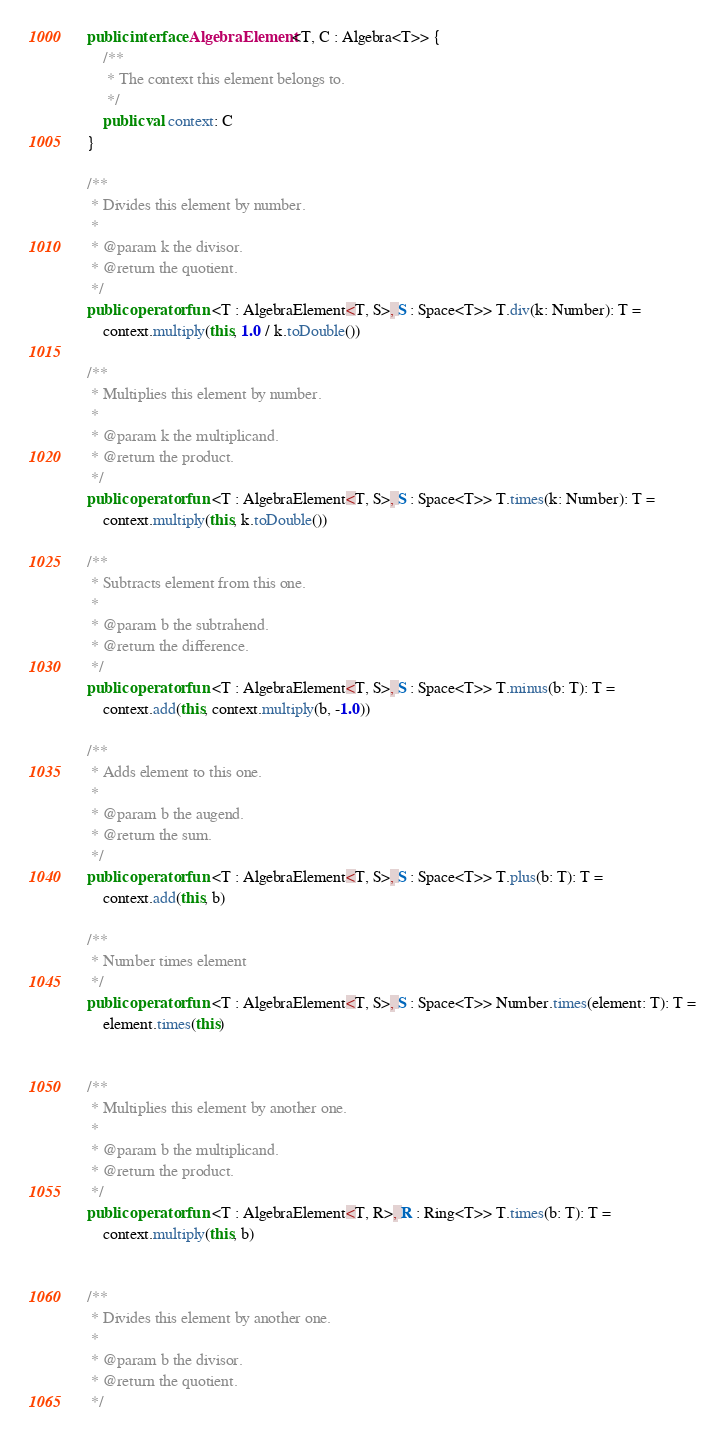Convert code to text. <code><loc_0><loc_0><loc_500><loc_500><_Kotlin_>public interface AlgebraElement<T, C : Algebra<T>> {
    /**
     * The context this element belongs to.
     */
    public val context: C
}

/**
 * Divides this element by number.
 *
 * @param k the divisor.
 * @return the quotient.
 */
public operator fun <T : AlgebraElement<T, S>, S : Space<T>> T.div(k: Number): T =
    context.multiply(this, 1.0 / k.toDouble())

/**
 * Multiplies this element by number.
 *
 * @param k the multiplicand.
 * @return the product.
 */
public operator fun <T : AlgebraElement<T, S>, S : Space<T>> T.times(k: Number): T =
    context.multiply(this, k.toDouble())

/**
 * Subtracts element from this one.
 *
 * @param b the subtrahend.
 * @return the difference.
 */
public operator fun <T : AlgebraElement<T, S>, S : Space<T>> T.minus(b: T): T =
    context.add(this, context.multiply(b, -1.0))

/**
 * Adds element to this one.
 *
 * @param b the augend.
 * @return the sum.
 */
public operator fun <T : AlgebraElement<T, S>, S : Space<T>> T.plus(b: T): T =
    context.add(this, b)

/**
 * Number times element
 */
public operator fun <T : AlgebraElement<T, S>, S : Space<T>> Number.times(element: T): T =
    element.times(this)


/**
 * Multiplies this element by another one.
 *
 * @param b the multiplicand.
 * @return the product.
 */
public operator fun <T : AlgebraElement<T, R>, R : Ring<T>> T.times(b: T): T =
    context.multiply(this, b)


/**
 * Divides this element by another one.
 *
 * @param b the divisor.
 * @return the quotient.
 */</code> 